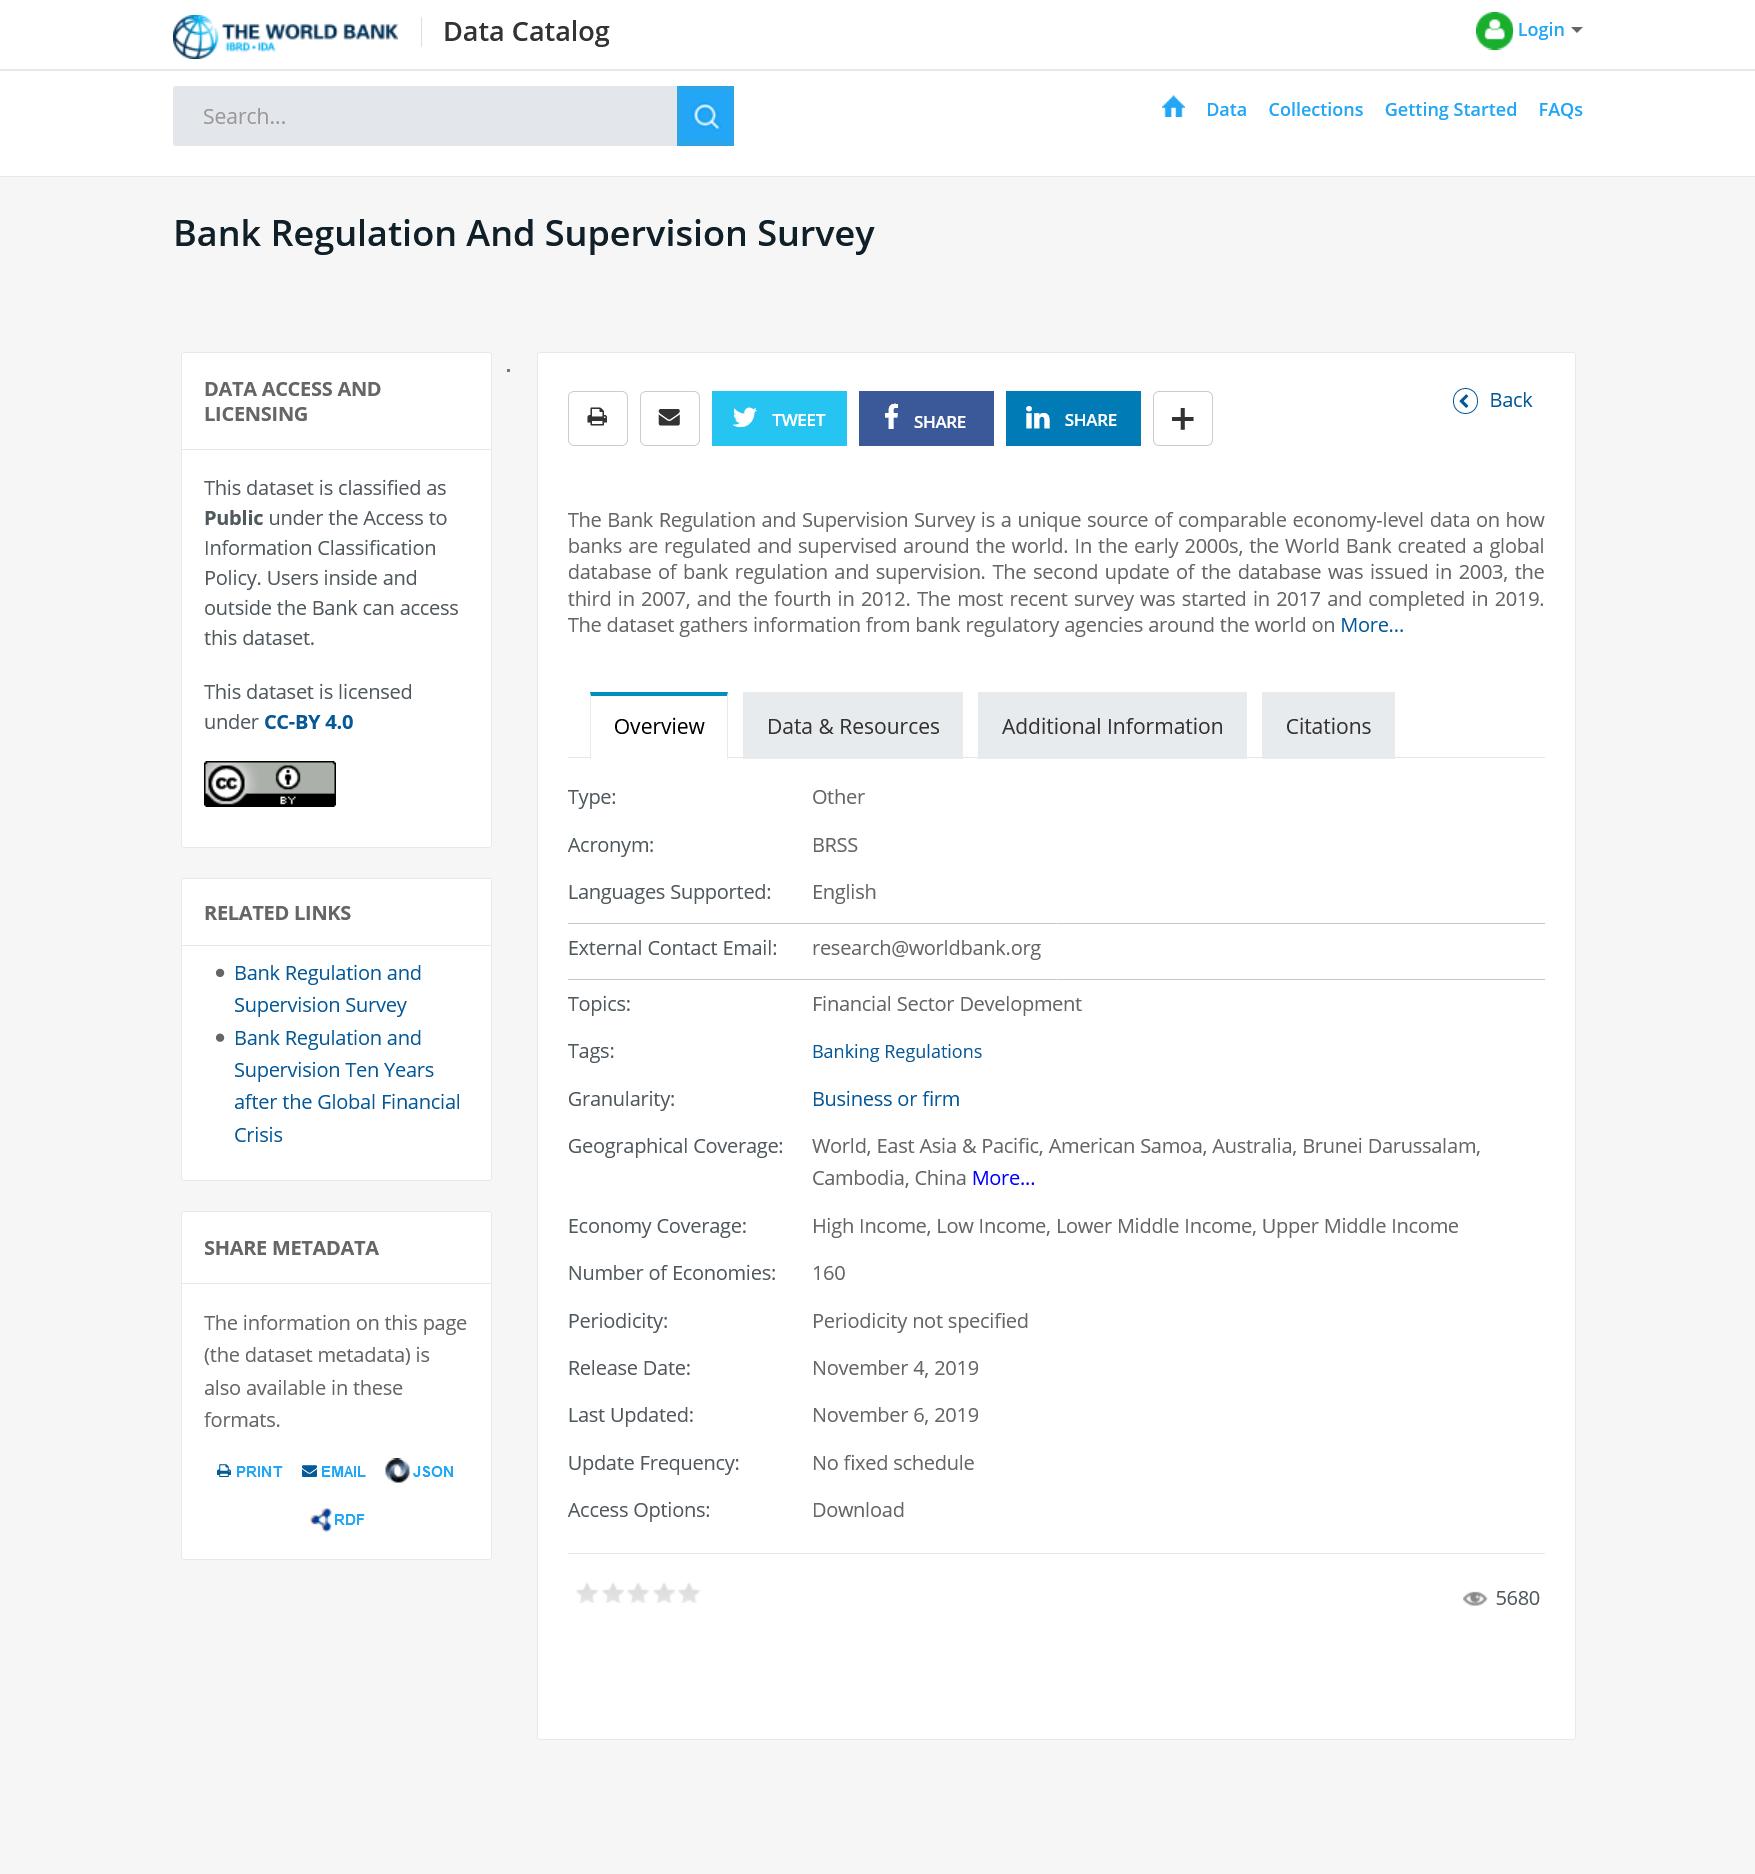Identify some key points in this picture. The title of this article is "Bank Regulation and Supervision Survey," and it is classified as public. The second update of the database was issued in 2003. This article can be shared on various social media platforms, including Twitter, Facebook, and Instagram. 